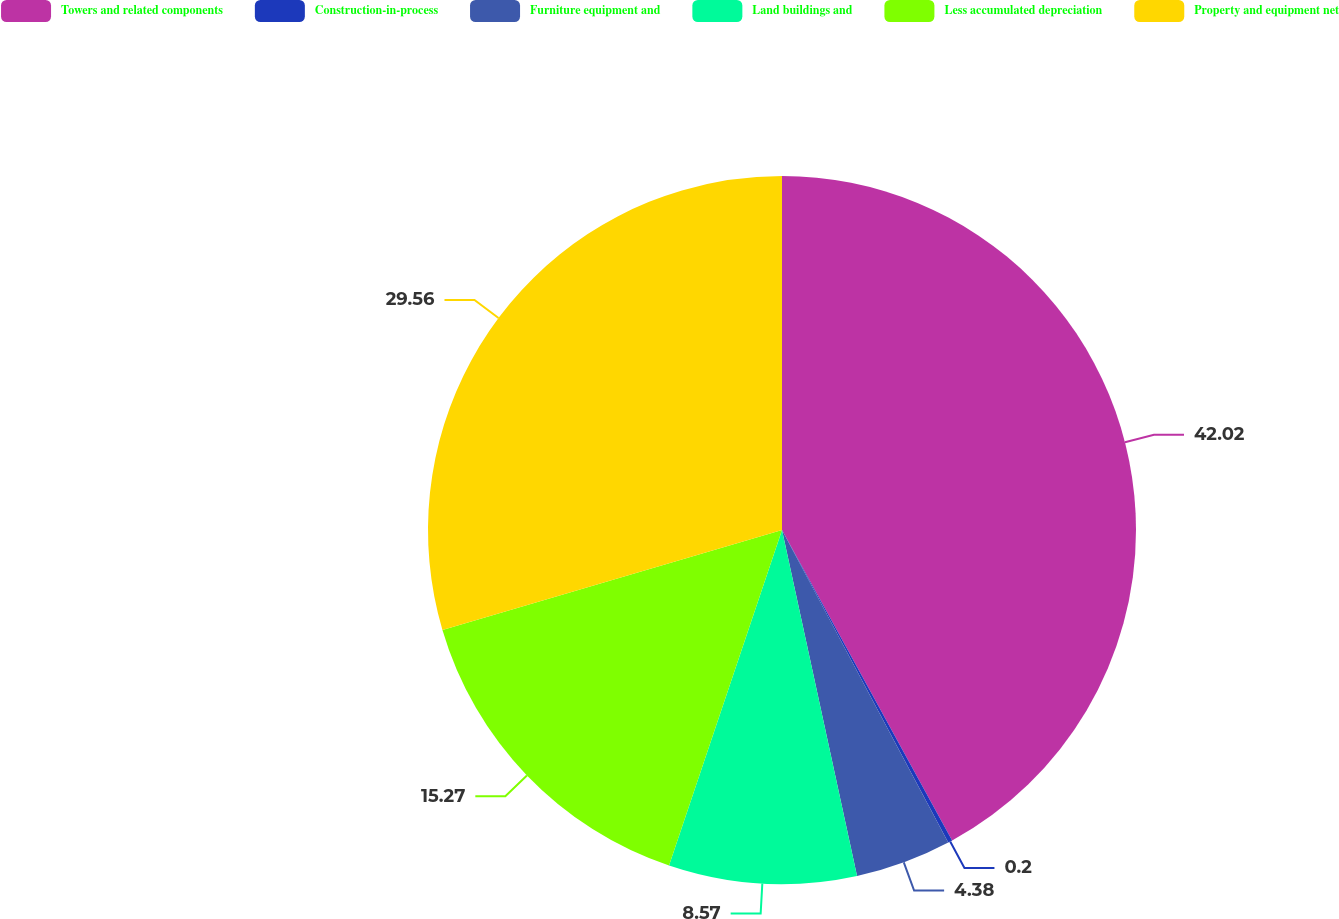<chart> <loc_0><loc_0><loc_500><loc_500><pie_chart><fcel>Towers and related components<fcel>Construction-in-process<fcel>Furniture equipment and<fcel>Land buildings and<fcel>Less accumulated depreciation<fcel>Property and equipment net<nl><fcel>42.02%<fcel>0.2%<fcel>4.38%<fcel>8.57%<fcel>15.27%<fcel>29.56%<nl></chart> 